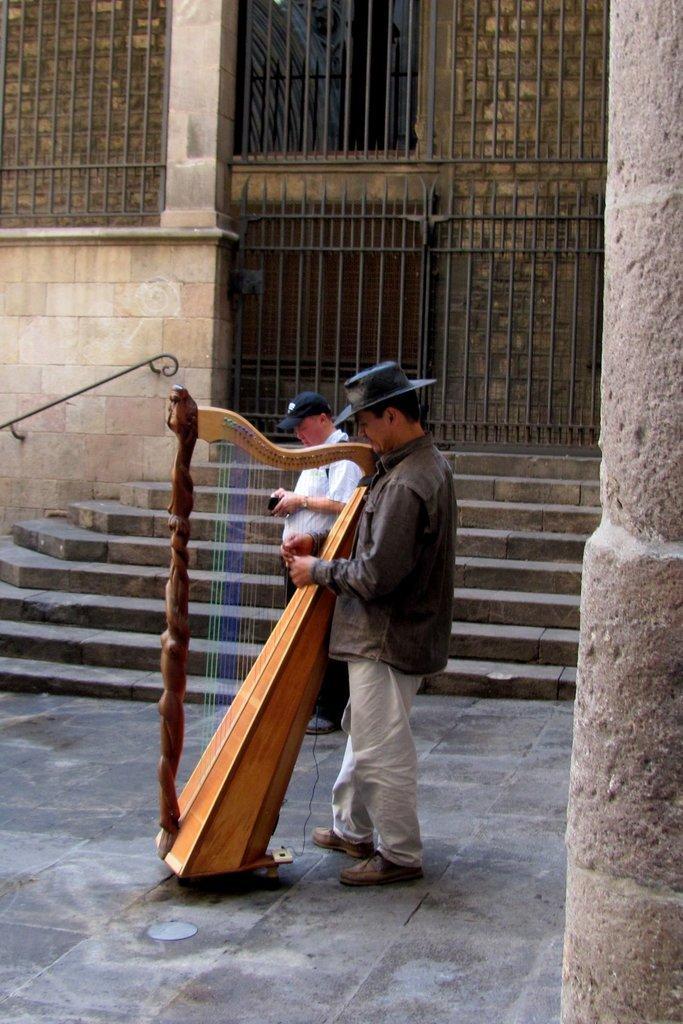In one or two sentences, can you explain what this image depicts? In this image I can see there are two persons wearing a cap and I can see a musical instrument visible on the floor and staircase and a fence visible in the middle and I can see the wall in the middle I can see a beam on the right side. 